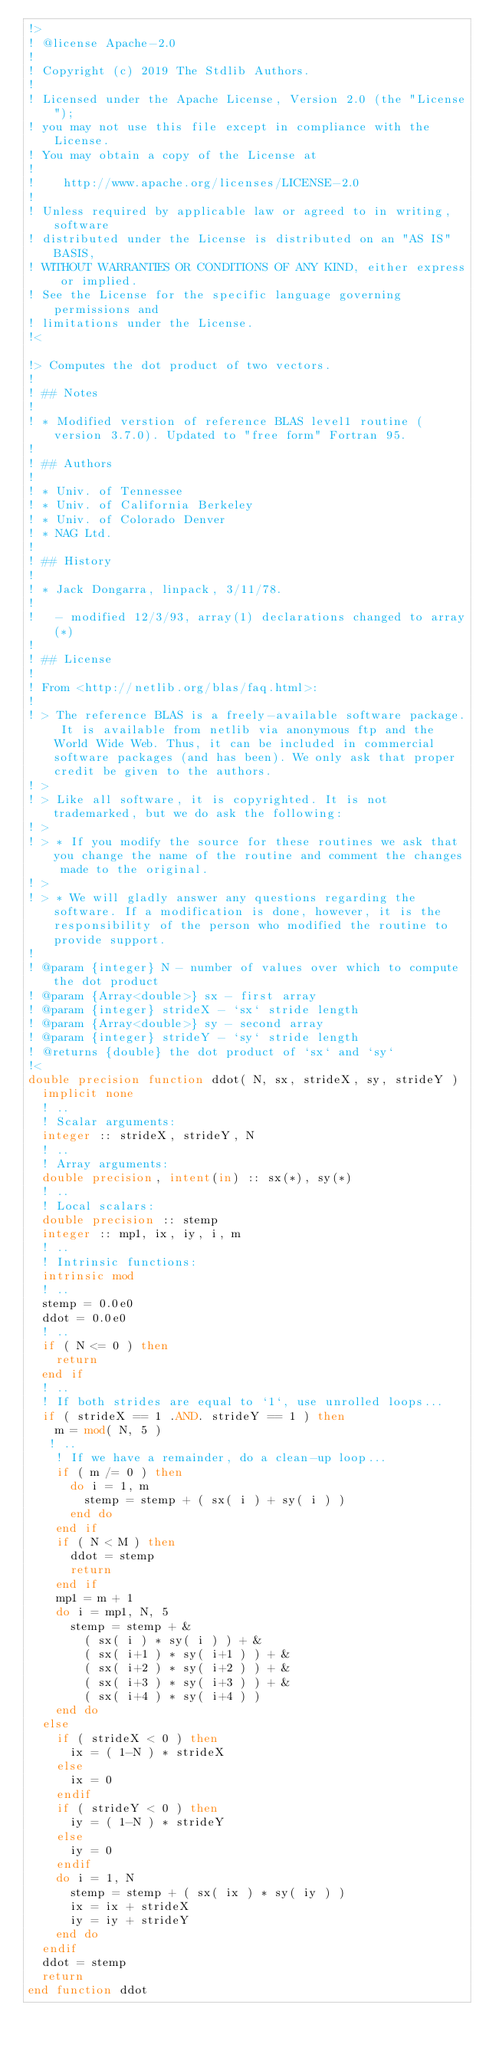Convert code to text. <code><loc_0><loc_0><loc_500><loc_500><_FORTRAN_>!>
! @license Apache-2.0
!
! Copyright (c) 2019 The Stdlib Authors.
!
! Licensed under the Apache License, Version 2.0 (the "License");
! you may not use this file except in compliance with the License.
! You may obtain a copy of the License at
!
!    http://www.apache.org/licenses/LICENSE-2.0
!
! Unless required by applicable law or agreed to in writing, software
! distributed under the License is distributed on an "AS IS" BASIS,
! WITHOUT WARRANTIES OR CONDITIONS OF ANY KIND, either express or implied.
! See the License for the specific language governing permissions and
! limitations under the License.
!<

!> Computes the dot product of two vectors.
!
! ## Notes
!
! * Modified verstion of reference BLAS level1 routine (version 3.7.0). Updated to "free form" Fortran 95.
!
! ## Authors
!
! * Univ. of Tennessee
! * Univ. of California Berkeley
! * Univ. of Colorado Denver
! * NAG Ltd.
!
! ## History
!
! * Jack Dongarra, linpack, 3/11/78.
!
!   - modified 12/3/93, array(1) declarations changed to array(*)
!
! ## License
!
! From <http://netlib.org/blas/faq.html>:
!
! > The reference BLAS is a freely-available software package. It is available from netlib via anonymous ftp and the World Wide Web. Thus, it can be included in commercial software packages (and has been). We only ask that proper credit be given to the authors.
! >
! > Like all software, it is copyrighted. It is not trademarked, but we do ask the following:
! >
! > * If you modify the source for these routines we ask that you change the name of the routine and comment the changes made to the original.
! >
! > * We will gladly answer any questions regarding the software. If a modification is done, however, it is the responsibility of the person who modified the routine to provide support.
!
! @param {integer} N - number of values over which to compute the dot product
! @param {Array<double>} sx - first array
! @param {integer} strideX - `sx` stride length
! @param {Array<double>} sy - second array
! @param {integer} strideY - `sy` stride length
! @returns {double} the dot product of `sx` and `sy`
!<
double precision function ddot( N, sx, strideX, sy, strideY )
  implicit none
  ! ..
  ! Scalar arguments:
  integer :: strideX, strideY, N
  ! ..
  ! Array arguments:
  double precision, intent(in) :: sx(*), sy(*)
  ! ..
  ! Local scalars:
  double precision :: stemp
  integer :: mp1, ix, iy, i, m
  ! ..
  ! Intrinsic functions:
  intrinsic mod
  ! ..
  stemp = 0.0e0
  ddot = 0.0e0
  ! ..
  if ( N <= 0 ) then
    return
  end if
  ! ..
  ! If both strides are equal to `1`, use unrolled loops...
  if ( strideX == 1 .AND. strideY == 1 ) then
    m = mod( N, 5 )
   ! ..
    ! If we have a remainder, do a clean-up loop...
    if ( m /= 0 ) then
      do i = 1, m
        stemp = stemp + ( sx( i ) + sy( i ) )
      end do
    end if
    if ( N < M ) then
      ddot = stemp
      return
    end if
    mp1 = m + 1
    do i = mp1, N, 5
      stemp = stemp + &
        ( sx( i ) * sy( i ) ) + &
        ( sx( i+1 ) * sy( i+1 ) ) + &
        ( sx( i+2 ) * sy( i+2 ) ) + &
        ( sx( i+3 ) * sy( i+3 ) ) + &
        ( sx( i+4 ) * sy( i+4 ) )
    end do
  else
    if ( strideX < 0 ) then
      ix = ( 1-N ) * strideX
    else
      ix = 0
    endif
    if ( strideY < 0 ) then
      iy = ( 1-N ) * strideY
    else
      iy = 0
    endif
    do i = 1, N
      stemp = stemp + ( sx( ix ) * sy( iy ) )
      ix = ix + strideX
      iy = iy + strideY
    end do
  endif
  ddot = stemp
  return
end function ddot</code> 